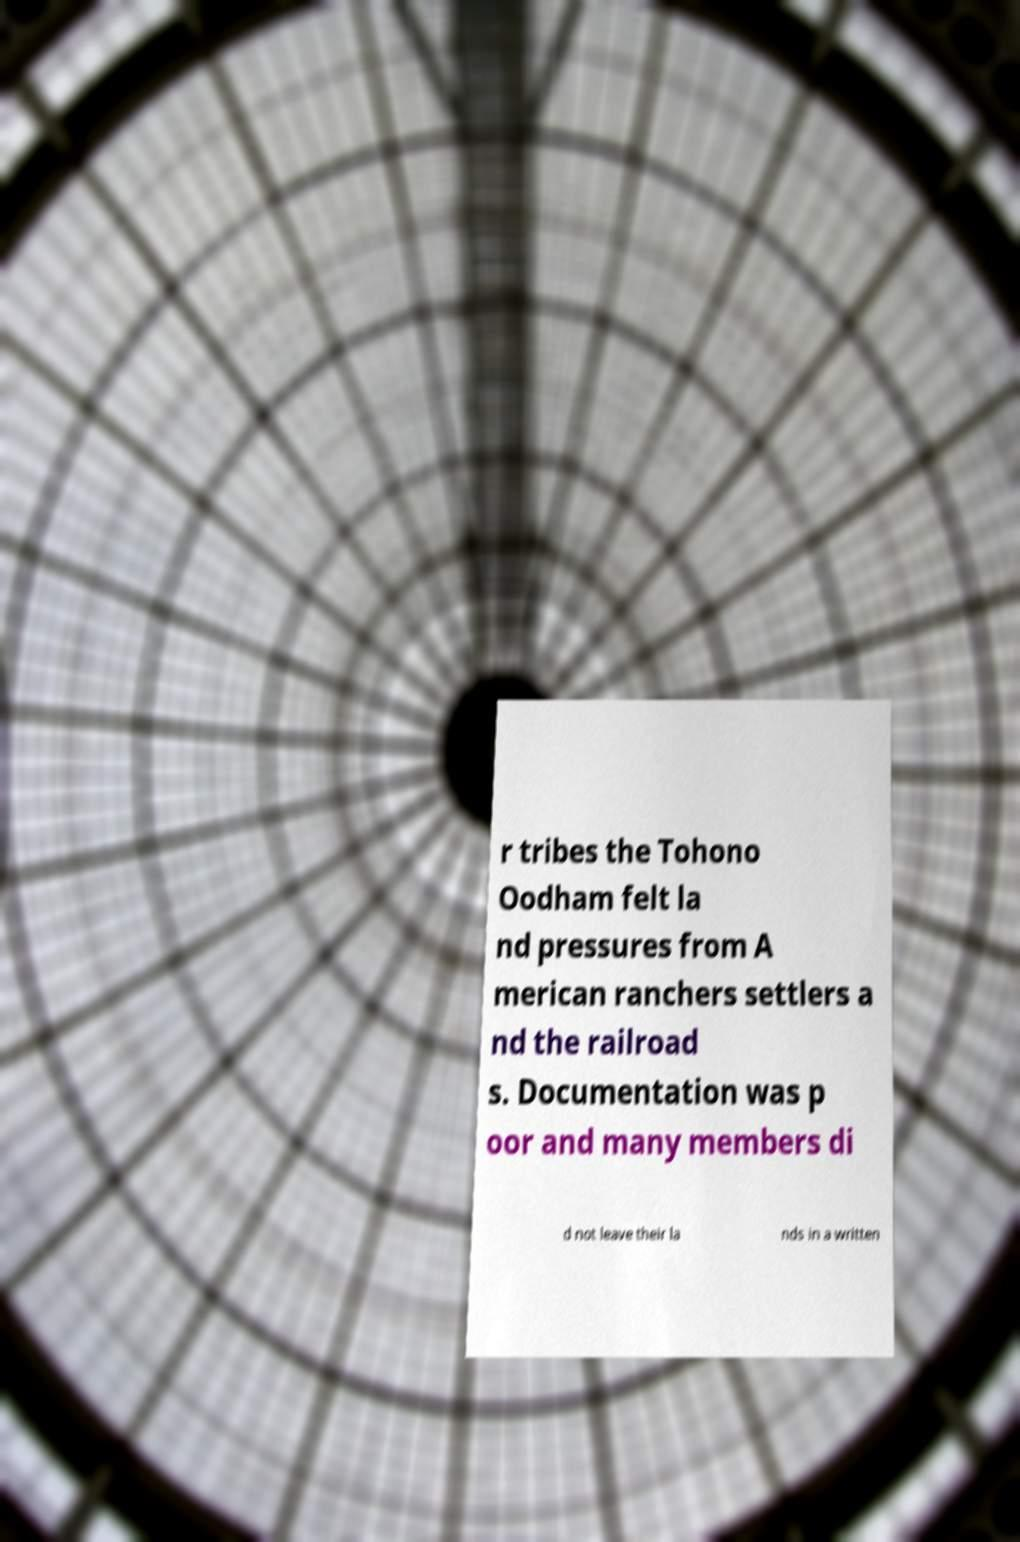Please read and relay the text visible in this image. What does it say? r tribes the Tohono Oodham felt la nd pressures from A merican ranchers settlers a nd the railroad s. Documentation was p oor and many members di d not leave their la nds in a written 